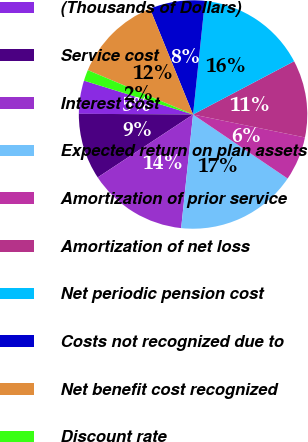Convert chart. <chart><loc_0><loc_0><loc_500><loc_500><pie_chart><fcel>(Thousands of Dollars)<fcel>Service cost<fcel>Interest cost<fcel>Expected return on plan assets<fcel>Amortization of prior service<fcel>Amortization of net loss<fcel>Net periodic pension cost<fcel>Costs not recognized due to<fcel>Net benefit cost recognized<fcel>Discount rate<nl><fcel>4.69%<fcel>9.38%<fcel>14.06%<fcel>17.19%<fcel>6.25%<fcel>10.94%<fcel>15.62%<fcel>7.81%<fcel>12.5%<fcel>1.56%<nl></chart> 